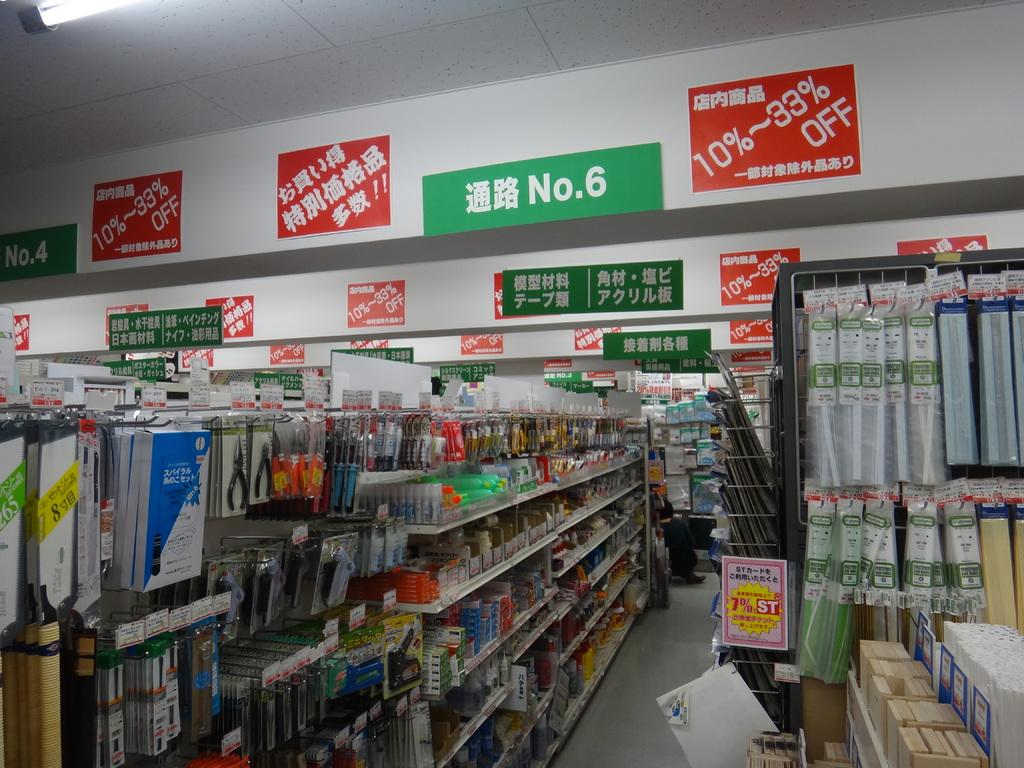What type of establishment is depicted in the image? The image appears to depict a store. What can be seen on the left side of the image? There are items for sale on the left side of the image. Can you describe a specific feature in the middle of the image? There is a green color board with the number 6 in the middle of the image. What type of tank is present in the image? There is no tank present in the image. What act is being performed by the team in the image? There is no team or act being performed in the image; it depicts a store with items for sale. 